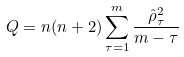Convert formula to latex. <formula><loc_0><loc_0><loc_500><loc_500>Q = n ( n + 2 ) \sum _ { \tau = 1 } ^ { m } \frac { \hat { \rho } ^ { 2 } _ { \tau } } { m - \tau }</formula> 